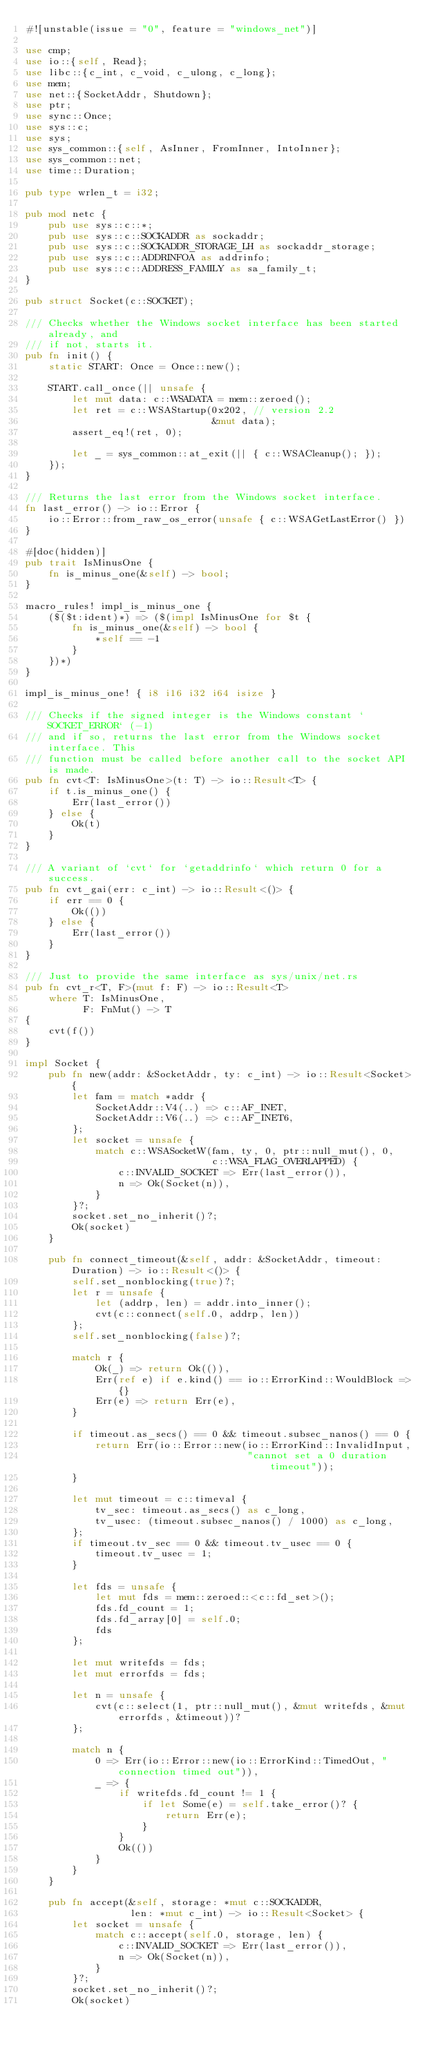Convert code to text. <code><loc_0><loc_0><loc_500><loc_500><_Rust_>#![unstable(issue = "0", feature = "windows_net")]

use cmp;
use io::{self, Read};
use libc::{c_int, c_void, c_ulong, c_long};
use mem;
use net::{SocketAddr, Shutdown};
use ptr;
use sync::Once;
use sys::c;
use sys;
use sys_common::{self, AsInner, FromInner, IntoInner};
use sys_common::net;
use time::Duration;

pub type wrlen_t = i32;

pub mod netc {
    pub use sys::c::*;
    pub use sys::c::SOCKADDR as sockaddr;
    pub use sys::c::SOCKADDR_STORAGE_LH as sockaddr_storage;
    pub use sys::c::ADDRINFOA as addrinfo;
    pub use sys::c::ADDRESS_FAMILY as sa_family_t;
}

pub struct Socket(c::SOCKET);

/// Checks whether the Windows socket interface has been started already, and
/// if not, starts it.
pub fn init() {
    static START: Once = Once::new();

    START.call_once(|| unsafe {
        let mut data: c::WSADATA = mem::zeroed();
        let ret = c::WSAStartup(0x202, // version 2.2
                                &mut data);
        assert_eq!(ret, 0);

        let _ = sys_common::at_exit(|| { c::WSACleanup(); });
    });
}

/// Returns the last error from the Windows socket interface.
fn last_error() -> io::Error {
    io::Error::from_raw_os_error(unsafe { c::WSAGetLastError() })
}

#[doc(hidden)]
pub trait IsMinusOne {
    fn is_minus_one(&self) -> bool;
}

macro_rules! impl_is_minus_one {
    ($($t:ident)*) => ($(impl IsMinusOne for $t {
        fn is_minus_one(&self) -> bool {
            *self == -1
        }
    })*)
}

impl_is_minus_one! { i8 i16 i32 i64 isize }

/// Checks if the signed integer is the Windows constant `SOCKET_ERROR` (-1)
/// and if so, returns the last error from the Windows socket interface. This
/// function must be called before another call to the socket API is made.
pub fn cvt<T: IsMinusOne>(t: T) -> io::Result<T> {
    if t.is_minus_one() {
        Err(last_error())
    } else {
        Ok(t)
    }
}

/// A variant of `cvt` for `getaddrinfo` which return 0 for a success.
pub fn cvt_gai(err: c_int) -> io::Result<()> {
    if err == 0 {
        Ok(())
    } else {
        Err(last_error())
    }
}

/// Just to provide the same interface as sys/unix/net.rs
pub fn cvt_r<T, F>(mut f: F) -> io::Result<T>
    where T: IsMinusOne,
          F: FnMut() -> T
{
    cvt(f())
}

impl Socket {
    pub fn new(addr: &SocketAddr, ty: c_int) -> io::Result<Socket> {
        let fam = match *addr {
            SocketAddr::V4(..) => c::AF_INET,
            SocketAddr::V6(..) => c::AF_INET6,
        };
        let socket = unsafe {
            match c::WSASocketW(fam, ty, 0, ptr::null_mut(), 0,
                                c::WSA_FLAG_OVERLAPPED) {
                c::INVALID_SOCKET => Err(last_error()),
                n => Ok(Socket(n)),
            }
        }?;
        socket.set_no_inherit()?;
        Ok(socket)
    }

    pub fn connect_timeout(&self, addr: &SocketAddr, timeout: Duration) -> io::Result<()> {
        self.set_nonblocking(true)?;
        let r = unsafe {
            let (addrp, len) = addr.into_inner();
            cvt(c::connect(self.0, addrp, len))
        };
        self.set_nonblocking(false)?;

        match r {
            Ok(_) => return Ok(()),
            Err(ref e) if e.kind() == io::ErrorKind::WouldBlock => {}
            Err(e) => return Err(e),
        }

        if timeout.as_secs() == 0 && timeout.subsec_nanos() == 0 {
            return Err(io::Error::new(io::ErrorKind::InvalidInput,
                                      "cannot set a 0 duration timeout"));
        }

        let mut timeout = c::timeval {
            tv_sec: timeout.as_secs() as c_long,
            tv_usec: (timeout.subsec_nanos() / 1000) as c_long,
        };
        if timeout.tv_sec == 0 && timeout.tv_usec == 0 {
            timeout.tv_usec = 1;
        }

        let fds = unsafe {
            let mut fds = mem::zeroed::<c::fd_set>();
            fds.fd_count = 1;
            fds.fd_array[0] = self.0;
            fds
        };

        let mut writefds = fds;
        let mut errorfds = fds;

        let n = unsafe {
            cvt(c::select(1, ptr::null_mut(), &mut writefds, &mut errorfds, &timeout))?
        };

        match n {
            0 => Err(io::Error::new(io::ErrorKind::TimedOut, "connection timed out")),
            _ => {
                if writefds.fd_count != 1 {
                    if let Some(e) = self.take_error()? {
                        return Err(e);
                    }
                }
                Ok(())
            }
        }
    }

    pub fn accept(&self, storage: *mut c::SOCKADDR,
                  len: *mut c_int) -> io::Result<Socket> {
        let socket = unsafe {
            match c::accept(self.0, storage, len) {
                c::INVALID_SOCKET => Err(last_error()),
                n => Ok(Socket(n)),
            }
        }?;
        socket.set_no_inherit()?;
        Ok(socket)</code> 